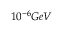<formula> <loc_0><loc_0><loc_500><loc_500>1 0 ^ { - 6 } G e V</formula> 